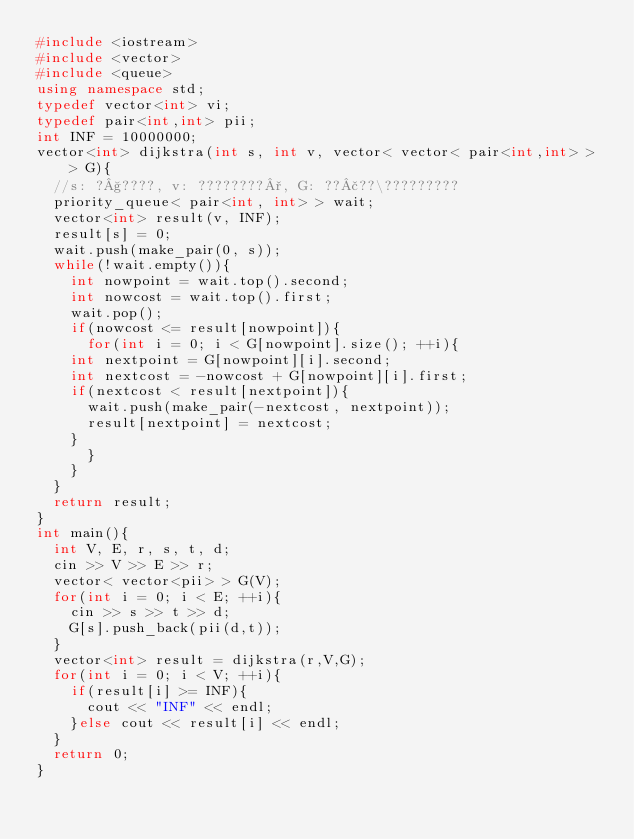Convert code to text. <code><loc_0><loc_0><loc_500><loc_500><_C++_>#include <iostream>
#include <vector>
#include <queue>
using namespace std;
typedef vector<int> vi;
typedef pair<int,int> pii;
int INF = 10000000;
vector<int> dijkstra(int s, int v, vector< vector< pair<int,int> > > G){
  //s: ?§????, v: ????????°, G: ??£??\?????????
  priority_queue< pair<int, int> > wait;
  vector<int> result(v, INF);
  result[s] = 0;
  wait.push(make_pair(0, s));
  while(!wait.empty()){
    int nowpoint = wait.top().second;
    int nowcost = wait.top().first;
    wait.pop();
    if(nowcost <= result[nowpoint]){
      for(int i = 0; i < G[nowpoint].size(); ++i){
	int nextpoint = G[nowpoint][i].second;
	int nextcost = -nowcost + G[nowpoint][i].first;
	if(nextcost < result[nextpoint]){
	  wait.push(make_pair(-nextcost, nextpoint));
	  result[nextpoint] = nextcost;
	}
      }
    }
  }
  return result;
}
int main(){
  int V, E, r, s, t, d;
  cin >> V >> E >> r;
  vector< vector<pii> > G(V);
  for(int i = 0; i < E; ++i){
    cin >> s >> t >> d;
    G[s].push_back(pii(d,t));
  }
  vector<int> result = dijkstra(r,V,G);
  for(int i = 0; i < V; ++i){
    if(result[i] >= INF){
      cout << "INF" << endl;
    }else cout << result[i] << endl;
  }
  return 0;
}</code> 